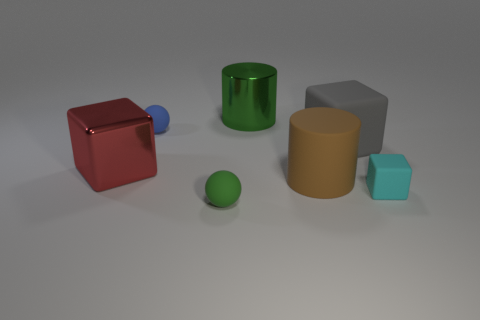Subtract 1 blocks. How many blocks are left? 2 Add 1 large metallic blocks. How many objects exist? 8 Subtract all spheres. How many objects are left? 5 Subtract 0 purple cylinders. How many objects are left? 7 Subtract all tiny green cylinders. Subtract all green rubber balls. How many objects are left? 6 Add 2 tiny balls. How many tiny balls are left? 4 Add 5 blue metallic cylinders. How many blue metallic cylinders exist? 5 